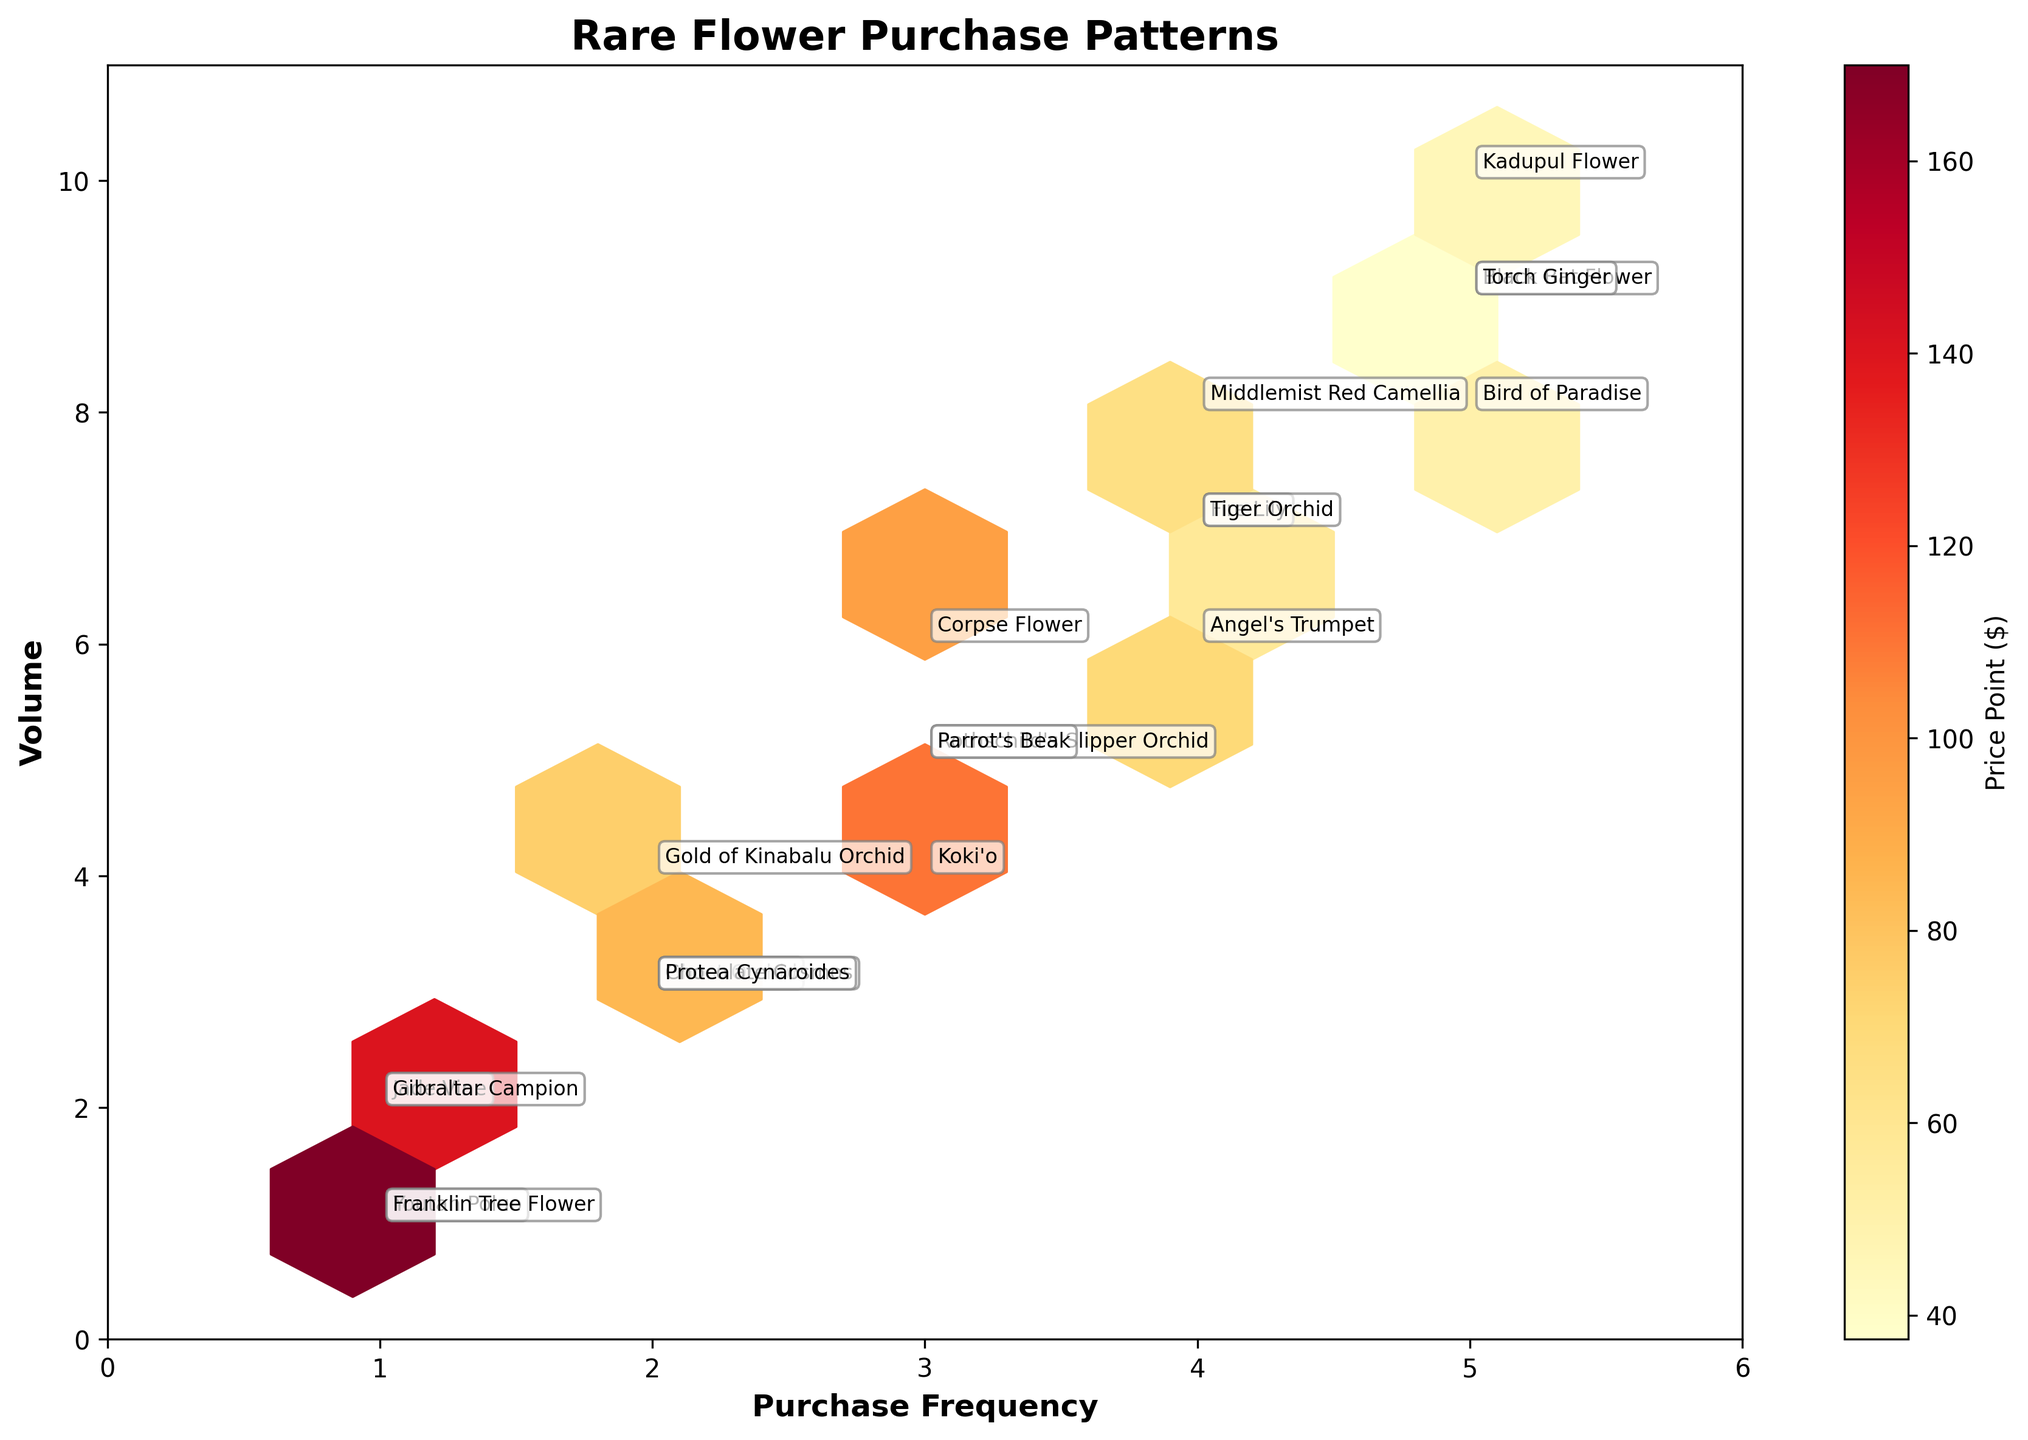What is the color palette used in the plot? The color palette used is a variation from light yellow to deep red, indicated by the color bar on the right side of the plot, representing different price points.
Answer: Yellow to Red What does the x-axis represent in the plot? The x-axis is labeled "Purchase Frequency," indicating how often customers buy the flowers.
Answer: Purchase Frequency Which flower type has the highest volume and purchase frequency combination? By looking at the data points, the flower type "Kadupul Flower" has the highest combined purchase frequency of 5 and volume of 10.
Answer: Kadupul Flower How is the color of each hexagon determined in the hexbin plot? The color of each hexagon in the plot is based on the price point of the flower varieties, with a gradient from light yellow to deep red showing lower to higher prices.
Answer: Price Point Which region of the hexbin plot has the most densely packed hexagons, and what does it signify? The most densely packed hexagons are around the coordinates (4, 6), suggesting that many flowers fall within a purchase frequency of 4 and a volume of 6.
Answer: Around (4, 6) How are "Youtan Poluo" and "Franklin Tree Flower" similar based on the plot? Both "Youtan Poluo" and "Franklin Tree Flower" have a low purchase frequency of 1 and a volume of 1, indicating similar purchasing patterns.
Answer: Low purchase frequency and volume What is the median price point of the flowers based on the hexbin colors in the plot? Looking at the color scale and evenly distributed colors from light to dark, the median price point appears to be around mid-range, correlating with colors around the mid-spectrum.
Answer: Mid-range Which flower type has the highest price point and how is it represented on the plot? "Youtan Poluo" has the highest price point of $180, shown by the darkest red hexagon near the coordinates (1, 1).
Answer: Youtan Poluo What does an annotated text near a hexagon signify? Annotated text near a hexagon indicates the specific flower type at that location on the plot.
Answer: Flower type What pattern can be observed for lower-priced flowers? Lower-priced flowers, represented by lighter colors (yellow), typically cluster around higher volumes and purchase frequencies (e.g., Kadupul Flower, Torch Ginger).
Answer: Cluster around higher volumes and purchase frequencies 